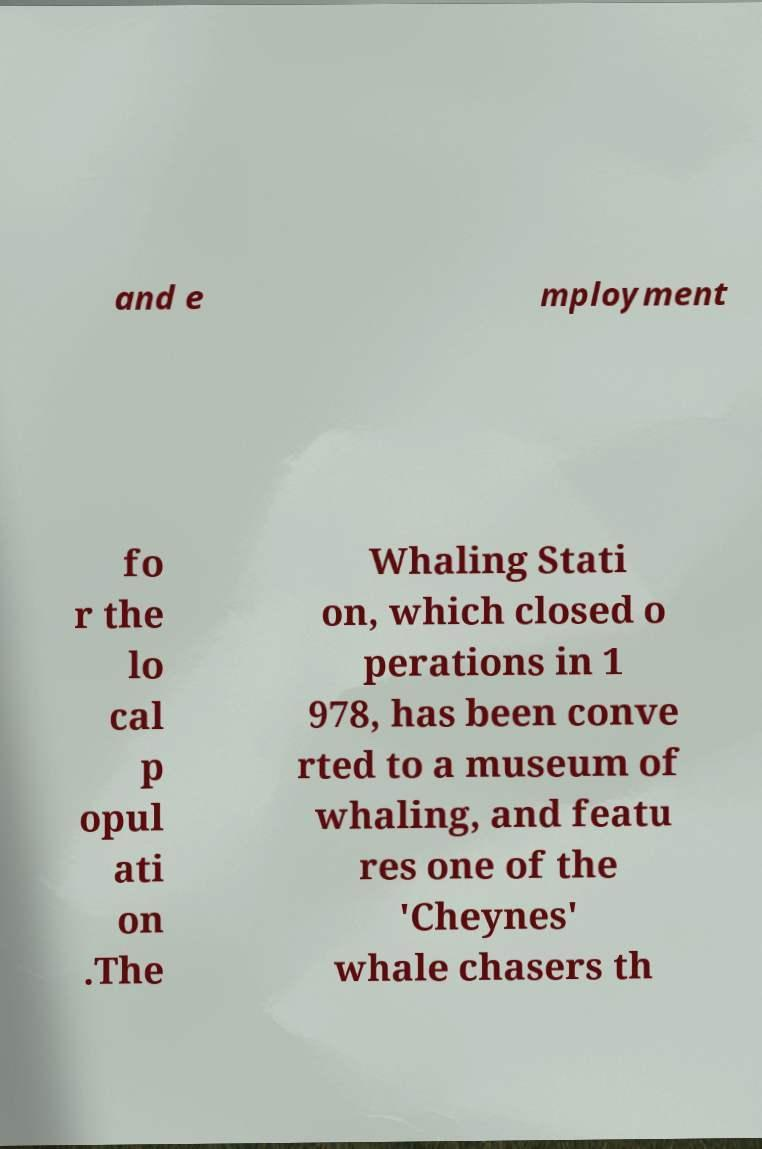Can you accurately transcribe the text from the provided image for me? and e mployment fo r the lo cal p opul ati on .The Whaling Stati on, which closed o perations in 1 978, has been conve rted to a museum of whaling, and featu res one of the 'Cheynes' whale chasers th 